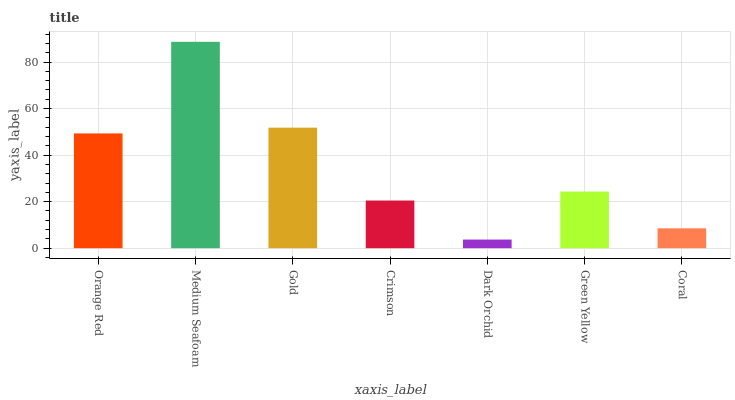Is Dark Orchid the minimum?
Answer yes or no. Yes. Is Medium Seafoam the maximum?
Answer yes or no. Yes. Is Gold the minimum?
Answer yes or no. No. Is Gold the maximum?
Answer yes or no. No. Is Medium Seafoam greater than Gold?
Answer yes or no. Yes. Is Gold less than Medium Seafoam?
Answer yes or no. Yes. Is Gold greater than Medium Seafoam?
Answer yes or no. No. Is Medium Seafoam less than Gold?
Answer yes or no. No. Is Green Yellow the high median?
Answer yes or no. Yes. Is Green Yellow the low median?
Answer yes or no. Yes. Is Crimson the high median?
Answer yes or no. No. Is Dark Orchid the low median?
Answer yes or no. No. 